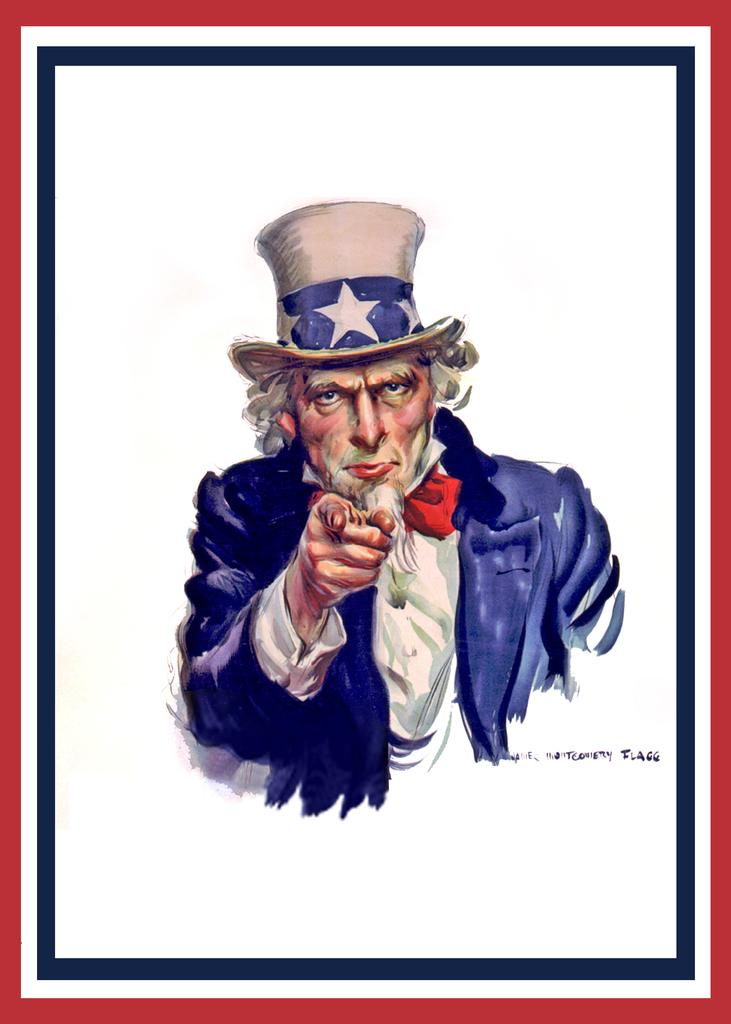What is depicted in the image? There is a drawing of a man in the image. What is the man wearing in the drawing? The man is wearing a blue coat and a hat. What is the distance between the man and the hook in the image? There is no hook present in the image, so it is not possible to determine the distance between the man and a hook. 